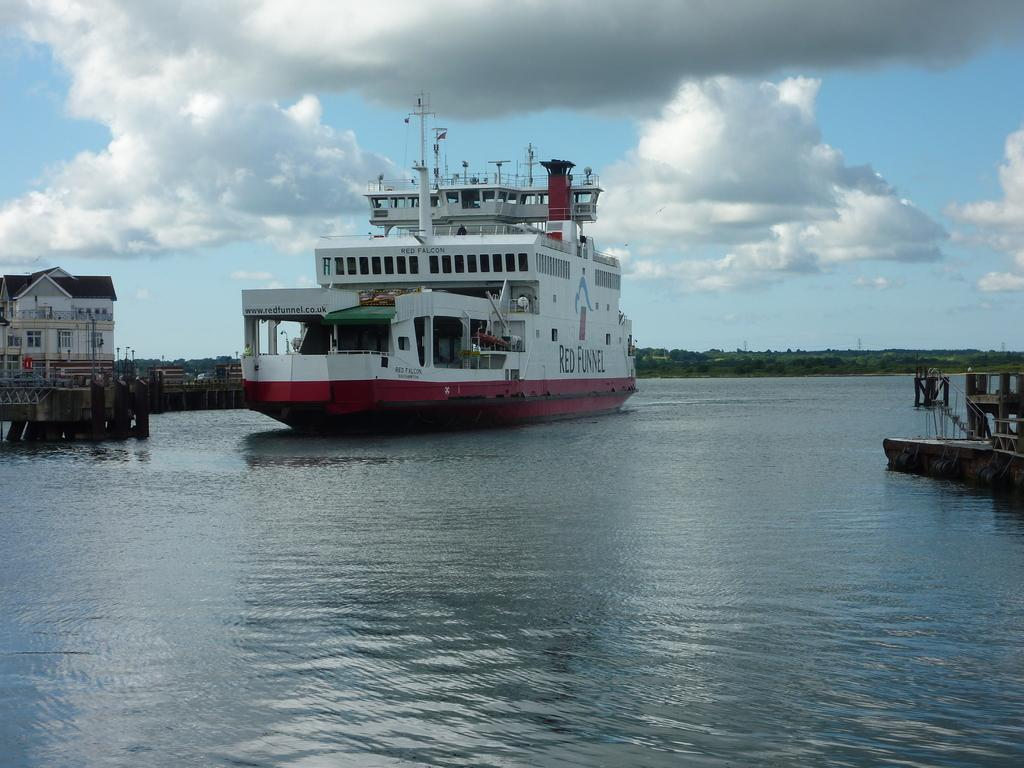What is the main subject of the image? The main subject of the image is a ship. Where is the ship located in the image? The ship is on the water in the image. What other structures or objects can be seen in the image? There is a house, a bridge with pillars, and trees visible in the image. How would you describe the weather in the image? The sky is cloudy in the image, suggesting a potentially overcast or rainy day. What type of songs can be heard coming from the hospital in the image? There is no hospital present in the image, so it's not possible to determine what, if any, songs might be heard. 